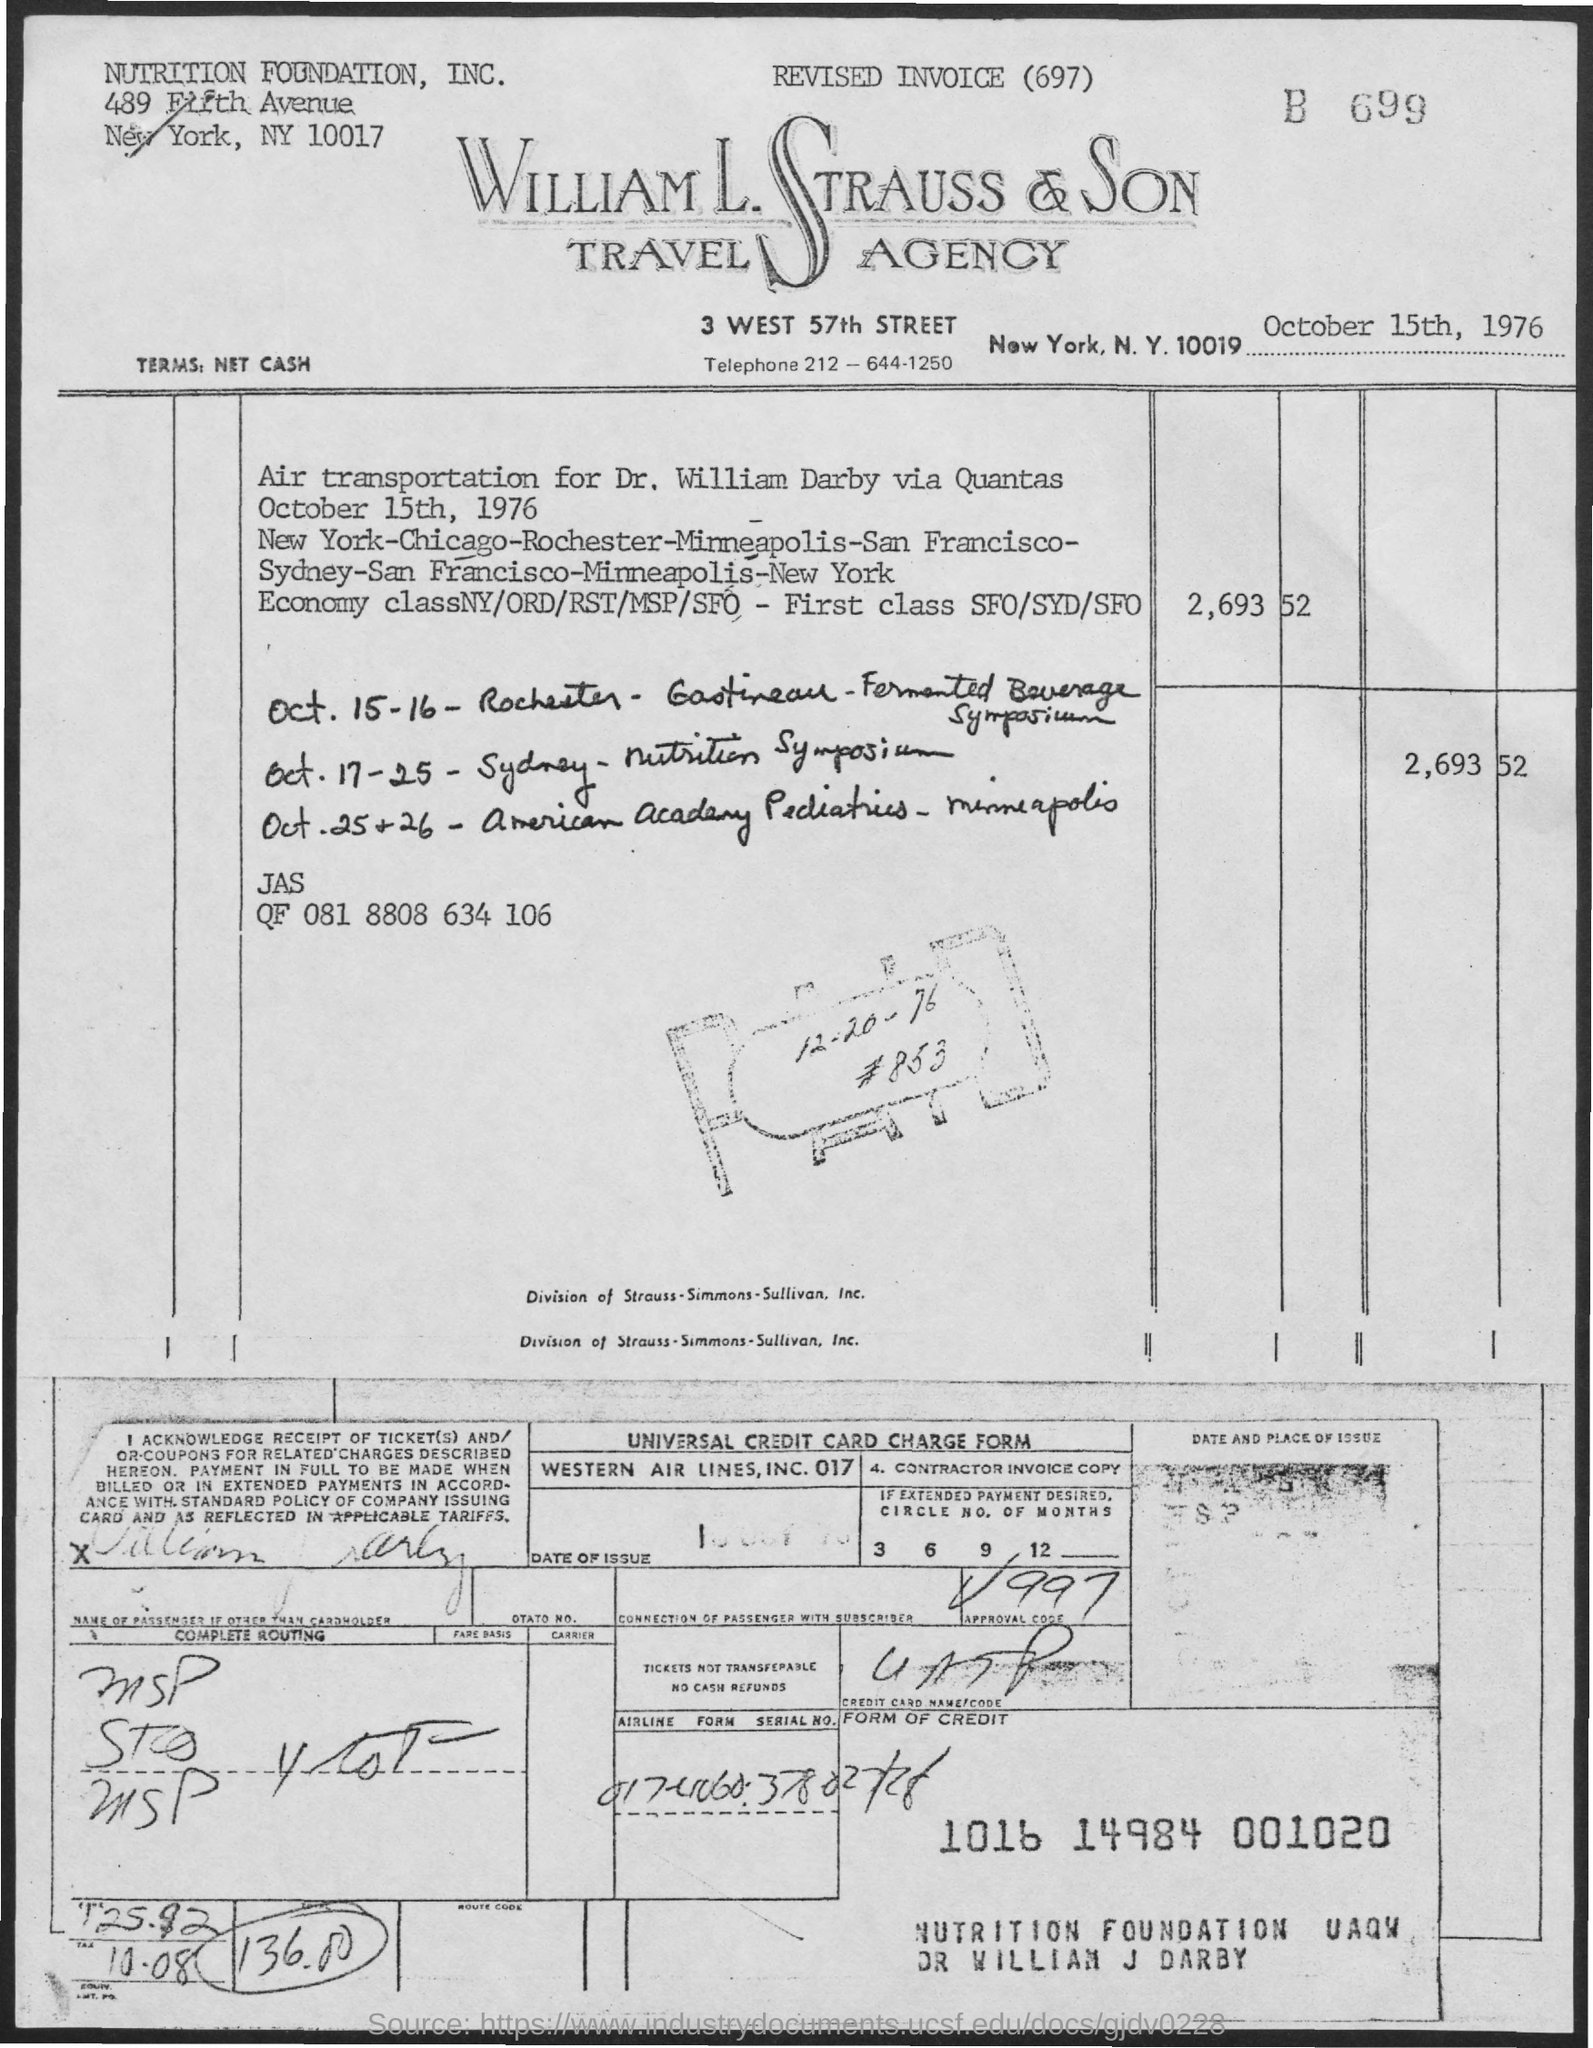What is the date mentioned in the top of the document ?
Your response must be concise. October 15th, 1976. What is the Telephone Number?
Make the answer very short. 212-644-1250. 